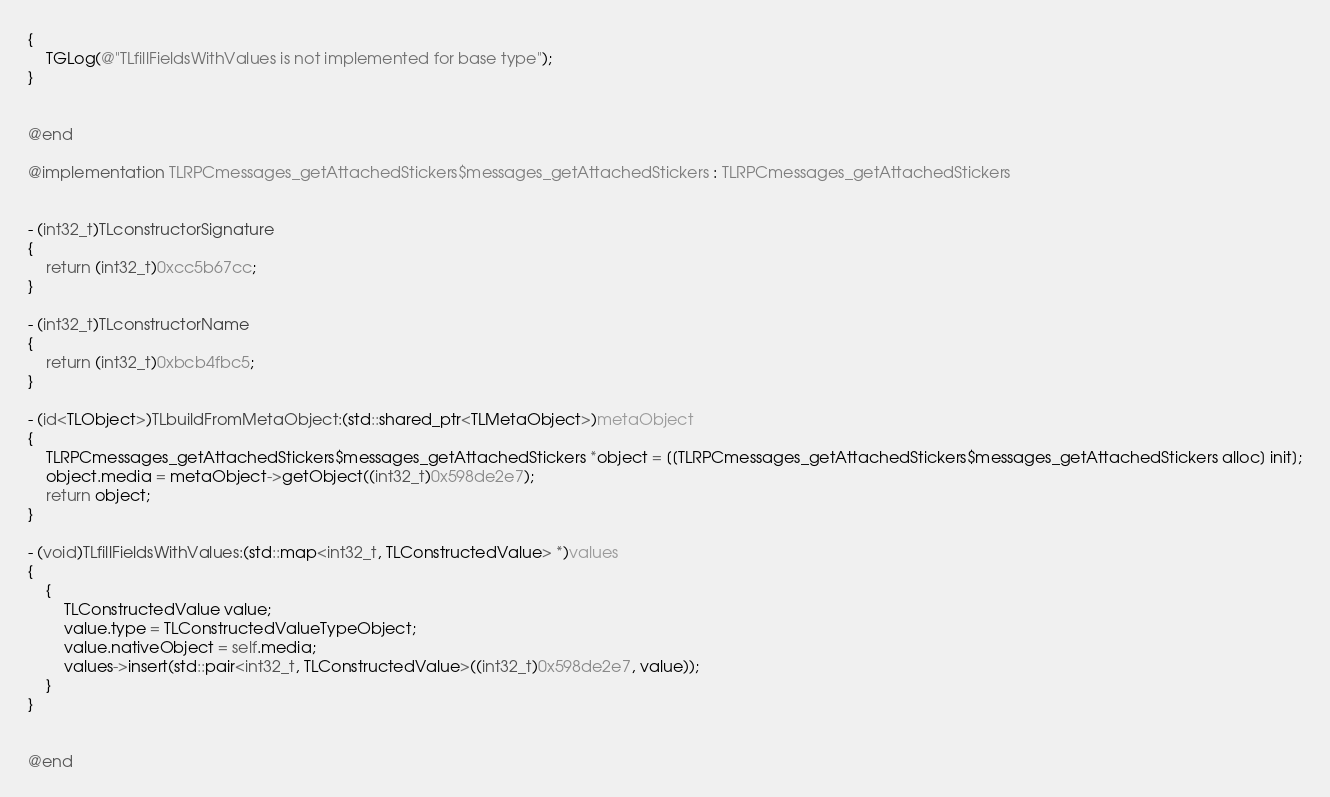<code> <loc_0><loc_0><loc_500><loc_500><_ObjectiveC_>{
    TGLog(@"TLfillFieldsWithValues is not implemented for base type");
}


@end

@implementation TLRPCmessages_getAttachedStickers$messages_getAttachedStickers : TLRPCmessages_getAttachedStickers


- (int32_t)TLconstructorSignature
{
    return (int32_t)0xcc5b67cc;
}

- (int32_t)TLconstructorName
{
    return (int32_t)0xbcb4fbc5;
}

- (id<TLObject>)TLbuildFromMetaObject:(std::shared_ptr<TLMetaObject>)metaObject
{
    TLRPCmessages_getAttachedStickers$messages_getAttachedStickers *object = [[TLRPCmessages_getAttachedStickers$messages_getAttachedStickers alloc] init];
    object.media = metaObject->getObject((int32_t)0x598de2e7);
    return object;
}

- (void)TLfillFieldsWithValues:(std::map<int32_t, TLConstructedValue> *)values
{
    {
        TLConstructedValue value;
        value.type = TLConstructedValueTypeObject;
        value.nativeObject = self.media;
        values->insert(std::pair<int32_t, TLConstructedValue>((int32_t)0x598de2e7, value));
    }
}


@end

</code> 